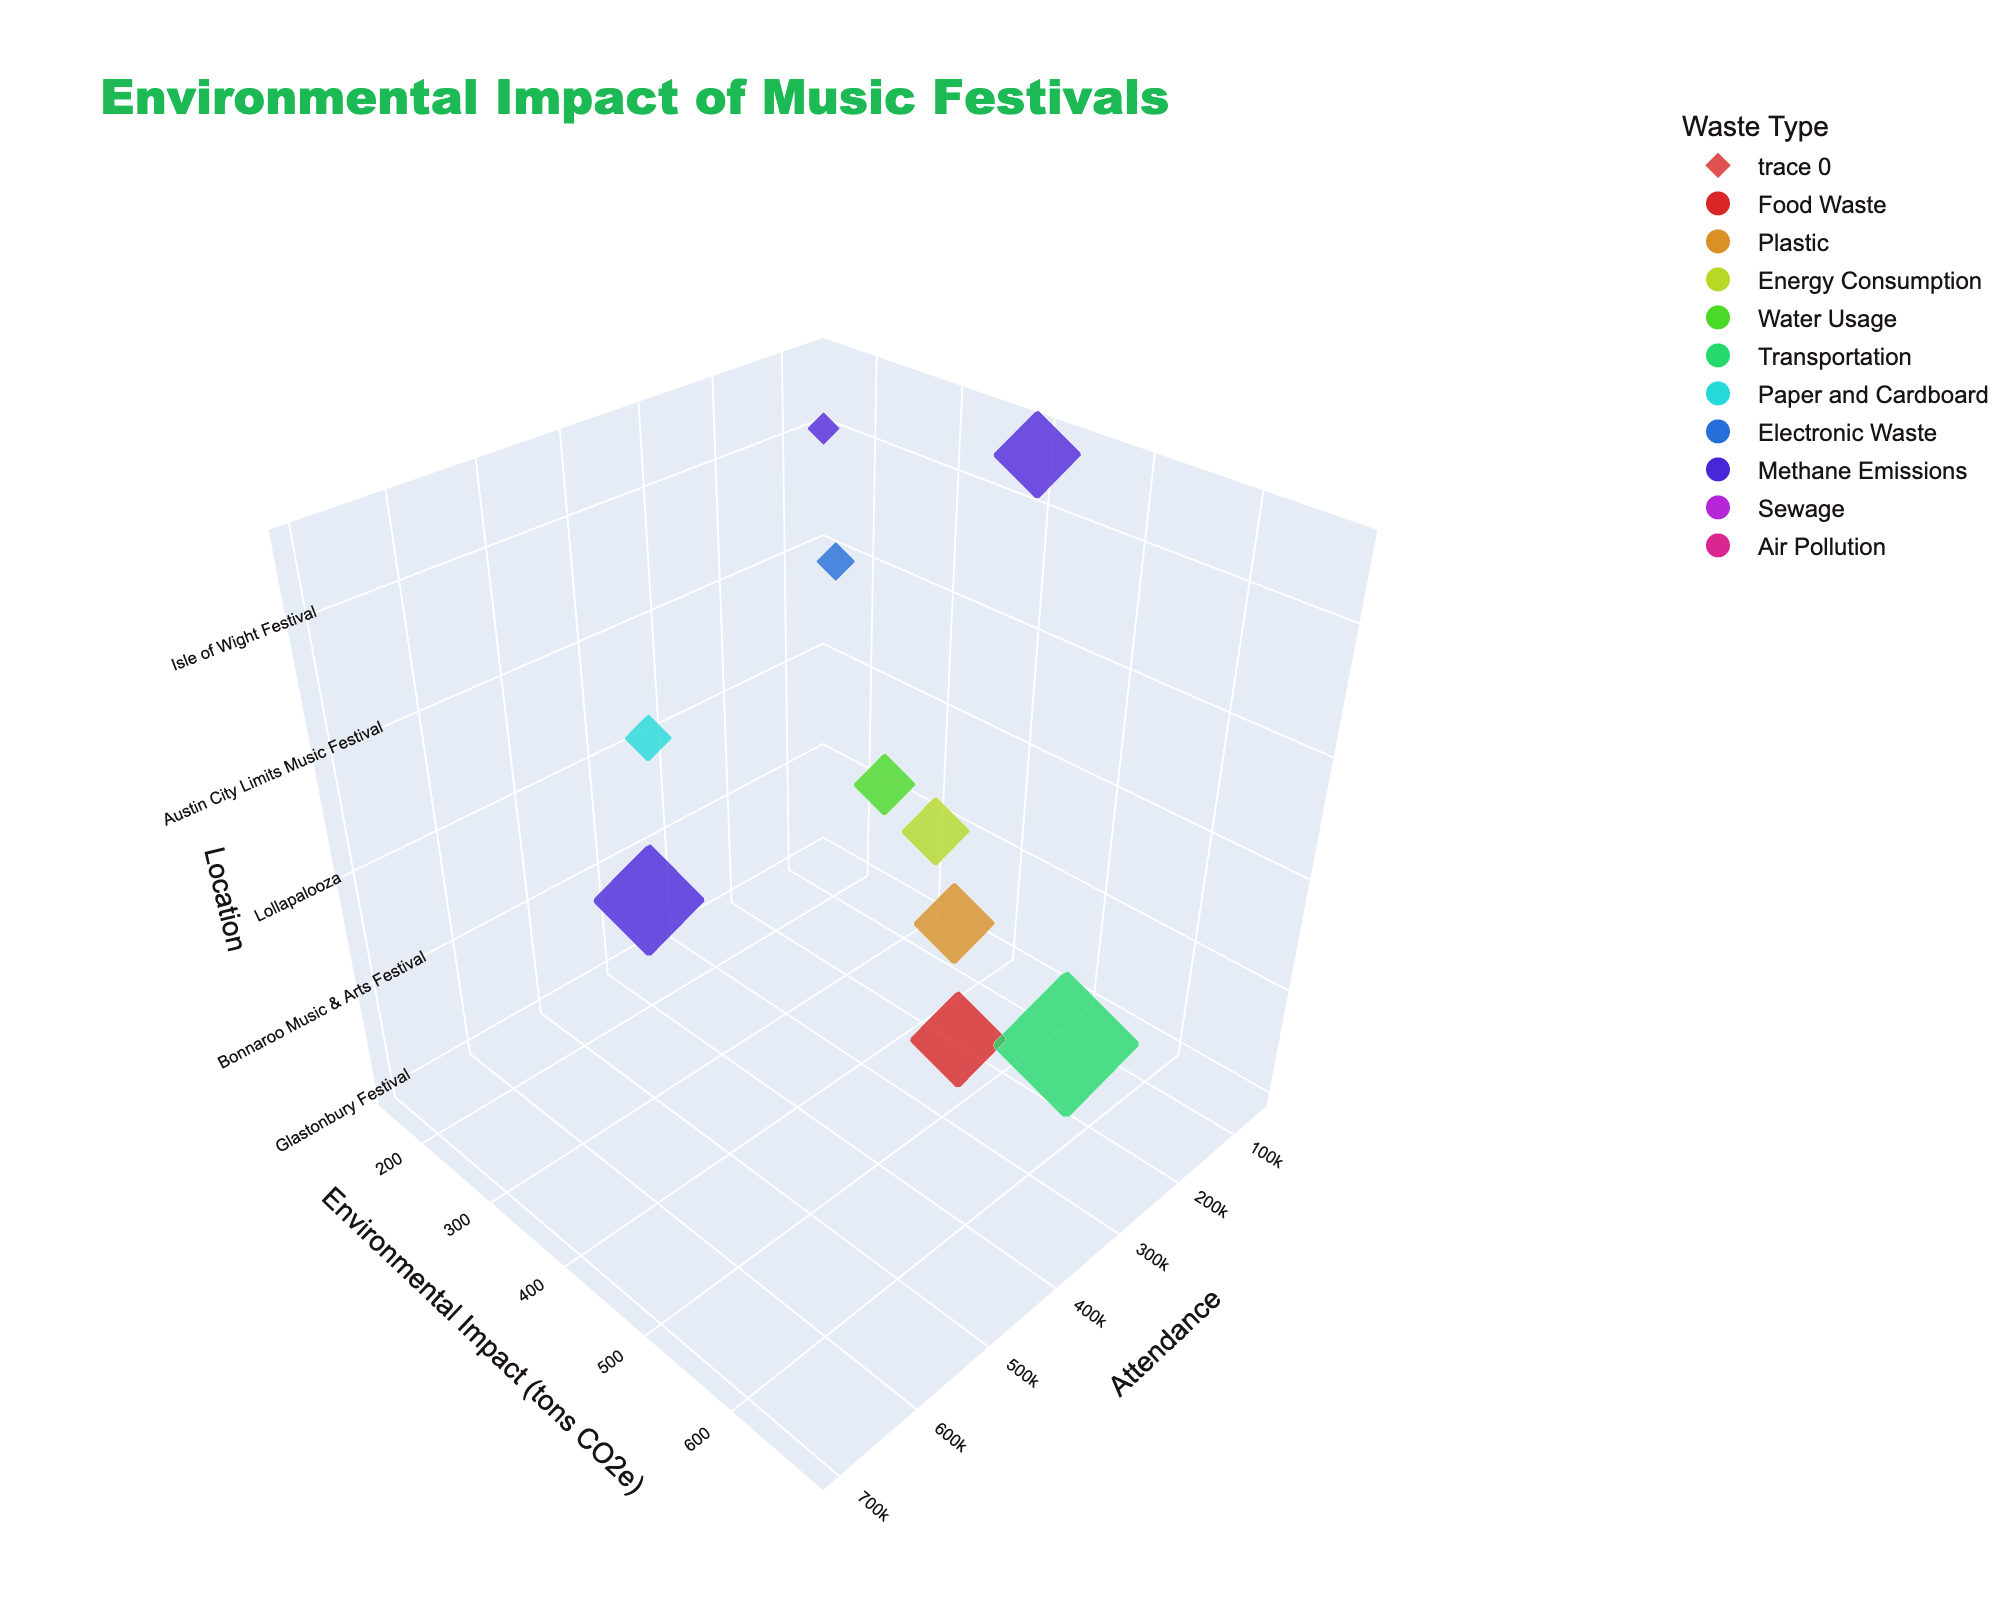What is the title of the 3D volume plot? The title of the plot is usually located at the top center of the figure.
Answer: Environmental Impact of Music Festivals Which axis represents the attendance size? The axis labels indicate which data each axis represents. In this plot, the x-axis is labeled 'Attendance'.
Answer: x-axis What is the waste type associated with the highest environmental impact? By examining the markers and their hover info, the highest environmental impact is 680 tons CO2e for Lollapalooza, associated with 'Transportation'.
Answer: Transportation Which festival has the lowest environmental impact and which waste type is associated with it? The lowest environmental impact can be identified by the smallest value on the y-axis. Isle of Wight Festival has the lowest impact at 150 tons CO2e, associated with 'Sewage'.
Answer: Isle of Wight Festival, Sewage How many festivals have an attendance size of over 300,000? Look at the x-axis values and count the number of points where attendance size is over 300,000.
Answer: 3 What is the average environmental impact of festivals with less than 100,000 attendees? Identify the festivals with attendance less than 100,000 from the x-axis, sum their environmental impacts, and divide by the number of those festivals. (Sum: 320 + 180 + 150 + 410 = 1060; Count: 4)
Answer: 265 tons CO2e Which festival has a higher environmental impact, Burning Man or Roskilde Festival? Compare the y-axis values for Burning Man (410 tons CO2e) and Roskilde Festival (290 tons CO2e).
Answer: Burning Man What waste type is Glastonbury Festival associated with? Check the hover info on the marker representing Glastonbury Festival, located with an attendance of 210,000.
Answer: Food Waste What is the total environmental impact of all festivals combined? Sum the environmental impact values of all the festivals: 450 + 380 + 320 + 290 + 680 + 220 + 180 + 520 + 150 + 410 = 3600
Answer: 3600 tons CO2e Are there more festivals with an environmental impact above or below 300 tons CO2e? Count the number of points above 300 on the y-axis and compare it to the number of points below 300. Above: 6 (450, 380, 320, 680, 520, 410); Below: 4 (290, 220, 180, 150).
Answer: Above 